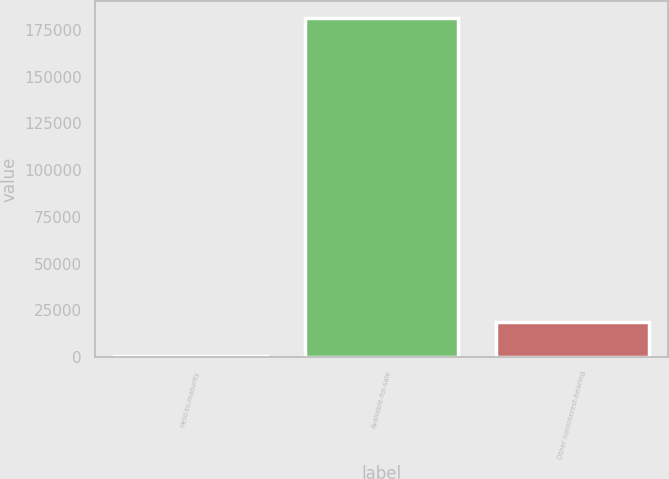Convert chart to OTSL. <chart><loc_0><loc_0><loc_500><loc_500><bar_chart><fcel>Held-to-maturity<fcel>Available-for-sale<fcel>Other noninterest-bearing<nl><fcel>403<fcel>181591<fcel>18521.8<nl></chart> 